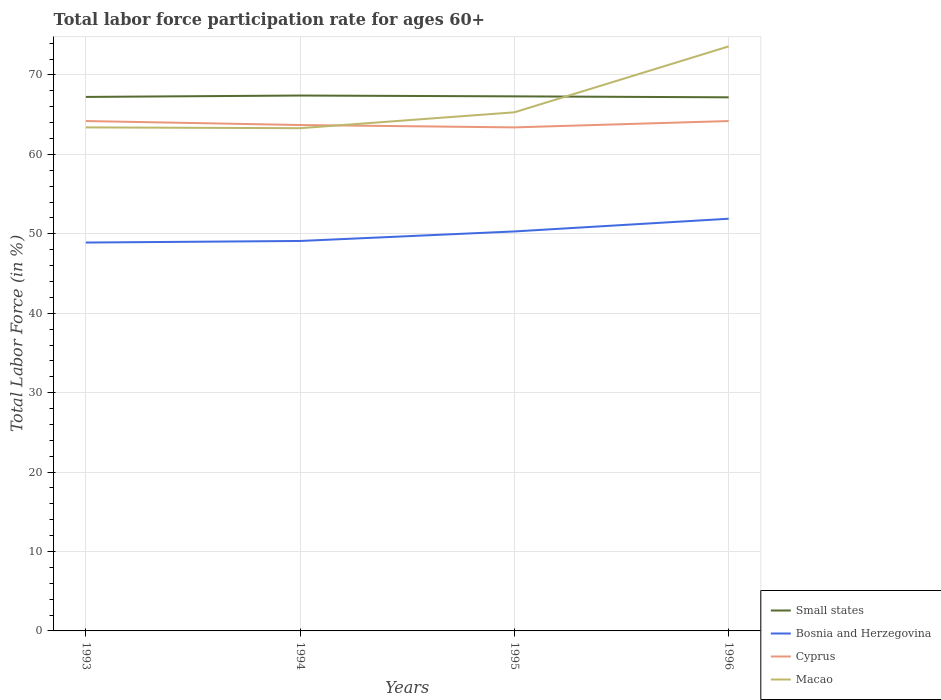How many different coloured lines are there?
Your answer should be compact. 4. Does the line corresponding to Cyprus intersect with the line corresponding to Bosnia and Herzegovina?
Give a very brief answer. No. Across all years, what is the maximum labor force participation rate in Small states?
Your answer should be very brief. 67.19. What is the total labor force participation rate in Cyprus in the graph?
Give a very brief answer. -0.5. What is the difference between the highest and the second highest labor force participation rate in Cyprus?
Provide a short and direct response. 0.8. What is the difference between the highest and the lowest labor force participation rate in Bosnia and Herzegovina?
Provide a short and direct response. 2. Is the labor force participation rate in Macao strictly greater than the labor force participation rate in Small states over the years?
Provide a succinct answer. No. How are the legend labels stacked?
Offer a very short reply. Vertical. What is the title of the graph?
Provide a succinct answer. Total labor force participation rate for ages 60+. What is the label or title of the Y-axis?
Offer a terse response. Total Labor Force (in %). What is the Total Labor Force (in %) of Small states in 1993?
Make the answer very short. 67.24. What is the Total Labor Force (in %) in Bosnia and Herzegovina in 1993?
Offer a terse response. 48.9. What is the Total Labor Force (in %) in Cyprus in 1993?
Give a very brief answer. 64.2. What is the Total Labor Force (in %) in Macao in 1993?
Offer a terse response. 63.4. What is the Total Labor Force (in %) of Small states in 1994?
Keep it short and to the point. 67.41. What is the Total Labor Force (in %) of Bosnia and Herzegovina in 1994?
Provide a short and direct response. 49.1. What is the Total Labor Force (in %) in Cyprus in 1994?
Keep it short and to the point. 63.7. What is the Total Labor Force (in %) of Macao in 1994?
Keep it short and to the point. 63.3. What is the Total Labor Force (in %) in Small states in 1995?
Ensure brevity in your answer.  67.31. What is the Total Labor Force (in %) of Bosnia and Herzegovina in 1995?
Make the answer very short. 50.3. What is the Total Labor Force (in %) in Cyprus in 1995?
Offer a terse response. 63.4. What is the Total Labor Force (in %) in Macao in 1995?
Provide a short and direct response. 65.3. What is the Total Labor Force (in %) of Small states in 1996?
Offer a very short reply. 67.19. What is the Total Labor Force (in %) in Bosnia and Herzegovina in 1996?
Provide a short and direct response. 51.9. What is the Total Labor Force (in %) in Cyprus in 1996?
Offer a very short reply. 64.2. What is the Total Labor Force (in %) of Macao in 1996?
Provide a succinct answer. 73.6. Across all years, what is the maximum Total Labor Force (in %) in Small states?
Ensure brevity in your answer.  67.41. Across all years, what is the maximum Total Labor Force (in %) of Bosnia and Herzegovina?
Your answer should be compact. 51.9. Across all years, what is the maximum Total Labor Force (in %) of Cyprus?
Provide a succinct answer. 64.2. Across all years, what is the maximum Total Labor Force (in %) in Macao?
Provide a short and direct response. 73.6. Across all years, what is the minimum Total Labor Force (in %) of Small states?
Your answer should be compact. 67.19. Across all years, what is the minimum Total Labor Force (in %) in Bosnia and Herzegovina?
Ensure brevity in your answer.  48.9. Across all years, what is the minimum Total Labor Force (in %) in Cyprus?
Offer a terse response. 63.4. Across all years, what is the minimum Total Labor Force (in %) of Macao?
Your answer should be very brief. 63.3. What is the total Total Labor Force (in %) in Small states in the graph?
Your answer should be compact. 269.14. What is the total Total Labor Force (in %) of Bosnia and Herzegovina in the graph?
Give a very brief answer. 200.2. What is the total Total Labor Force (in %) in Cyprus in the graph?
Offer a terse response. 255.5. What is the total Total Labor Force (in %) in Macao in the graph?
Your response must be concise. 265.6. What is the difference between the Total Labor Force (in %) of Small states in 1993 and that in 1994?
Your answer should be compact. -0.18. What is the difference between the Total Labor Force (in %) of Small states in 1993 and that in 1995?
Your answer should be very brief. -0.07. What is the difference between the Total Labor Force (in %) in Cyprus in 1993 and that in 1995?
Offer a terse response. 0.8. What is the difference between the Total Labor Force (in %) of Macao in 1993 and that in 1995?
Provide a short and direct response. -1.9. What is the difference between the Total Labor Force (in %) in Small states in 1993 and that in 1996?
Provide a succinct answer. 0.05. What is the difference between the Total Labor Force (in %) of Macao in 1993 and that in 1996?
Provide a short and direct response. -10.2. What is the difference between the Total Labor Force (in %) of Small states in 1994 and that in 1995?
Offer a terse response. 0.1. What is the difference between the Total Labor Force (in %) of Cyprus in 1994 and that in 1995?
Provide a short and direct response. 0.3. What is the difference between the Total Labor Force (in %) of Macao in 1994 and that in 1995?
Offer a terse response. -2. What is the difference between the Total Labor Force (in %) in Small states in 1994 and that in 1996?
Your answer should be very brief. 0.23. What is the difference between the Total Labor Force (in %) of Bosnia and Herzegovina in 1994 and that in 1996?
Your answer should be very brief. -2.8. What is the difference between the Total Labor Force (in %) in Cyprus in 1994 and that in 1996?
Provide a succinct answer. -0.5. What is the difference between the Total Labor Force (in %) of Small states in 1995 and that in 1996?
Make the answer very short. 0.12. What is the difference between the Total Labor Force (in %) in Bosnia and Herzegovina in 1995 and that in 1996?
Make the answer very short. -1.6. What is the difference between the Total Labor Force (in %) of Cyprus in 1995 and that in 1996?
Ensure brevity in your answer.  -0.8. What is the difference between the Total Labor Force (in %) of Small states in 1993 and the Total Labor Force (in %) of Bosnia and Herzegovina in 1994?
Give a very brief answer. 18.14. What is the difference between the Total Labor Force (in %) in Small states in 1993 and the Total Labor Force (in %) in Cyprus in 1994?
Keep it short and to the point. 3.54. What is the difference between the Total Labor Force (in %) in Small states in 1993 and the Total Labor Force (in %) in Macao in 1994?
Give a very brief answer. 3.94. What is the difference between the Total Labor Force (in %) in Bosnia and Herzegovina in 1993 and the Total Labor Force (in %) in Cyprus in 1994?
Make the answer very short. -14.8. What is the difference between the Total Labor Force (in %) in Bosnia and Herzegovina in 1993 and the Total Labor Force (in %) in Macao in 1994?
Offer a very short reply. -14.4. What is the difference between the Total Labor Force (in %) of Cyprus in 1993 and the Total Labor Force (in %) of Macao in 1994?
Offer a very short reply. 0.9. What is the difference between the Total Labor Force (in %) of Small states in 1993 and the Total Labor Force (in %) of Bosnia and Herzegovina in 1995?
Ensure brevity in your answer.  16.94. What is the difference between the Total Labor Force (in %) in Small states in 1993 and the Total Labor Force (in %) in Cyprus in 1995?
Provide a succinct answer. 3.84. What is the difference between the Total Labor Force (in %) in Small states in 1993 and the Total Labor Force (in %) in Macao in 1995?
Your response must be concise. 1.94. What is the difference between the Total Labor Force (in %) in Bosnia and Herzegovina in 1993 and the Total Labor Force (in %) in Macao in 1995?
Give a very brief answer. -16.4. What is the difference between the Total Labor Force (in %) of Cyprus in 1993 and the Total Labor Force (in %) of Macao in 1995?
Make the answer very short. -1.1. What is the difference between the Total Labor Force (in %) of Small states in 1993 and the Total Labor Force (in %) of Bosnia and Herzegovina in 1996?
Offer a terse response. 15.34. What is the difference between the Total Labor Force (in %) of Small states in 1993 and the Total Labor Force (in %) of Cyprus in 1996?
Offer a terse response. 3.04. What is the difference between the Total Labor Force (in %) of Small states in 1993 and the Total Labor Force (in %) of Macao in 1996?
Ensure brevity in your answer.  -6.36. What is the difference between the Total Labor Force (in %) in Bosnia and Herzegovina in 1993 and the Total Labor Force (in %) in Cyprus in 1996?
Keep it short and to the point. -15.3. What is the difference between the Total Labor Force (in %) in Bosnia and Herzegovina in 1993 and the Total Labor Force (in %) in Macao in 1996?
Your answer should be compact. -24.7. What is the difference between the Total Labor Force (in %) in Cyprus in 1993 and the Total Labor Force (in %) in Macao in 1996?
Your response must be concise. -9.4. What is the difference between the Total Labor Force (in %) in Small states in 1994 and the Total Labor Force (in %) in Bosnia and Herzegovina in 1995?
Make the answer very short. 17.11. What is the difference between the Total Labor Force (in %) of Small states in 1994 and the Total Labor Force (in %) of Cyprus in 1995?
Ensure brevity in your answer.  4.01. What is the difference between the Total Labor Force (in %) of Small states in 1994 and the Total Labor Force (in %) of Macao in 1995?
Provide a succinct answer. 2.11. What is the difference between the Total Labor Force (in %) of Bosnia and Herzegovina in 1994 and the Total Labor Force (in %) of Cyprus in 1995?
Your response must be concise. -14.3. What is the difference between the Total Labor Force (in %) of Bosnia and Herzegovina in 1994 and the Total Labor Force (in %) of Macao in 1995?
Provide a succinct answer. -16.2. What is the difference between the Total Labor Force (in %) of Small states in 1994 and the Total Labor Force (in %) of Bosnia and Herzegovina in 1996?
Provide a succinct answer. 15.51. What is the difference between the Total Labor Force (in %) in Small states in 1994 and the Total Labor Force (in %) in Cyprus in 1996?
Give a very brief answer. 3.21. What is the difference between the Total Labor Force (in %) of Small states in 1994 and the Total Labor Force (in %) of Macao in 1996?
Offer a terse response. -6.19. What is the difference between the Total Labor Force (in %) in Bosnia and Herzegovina in 1994 and the Total Labor Force (in %) in Cyprus in 1996?
Your answer should be compact. -15.1. What is the difference between the Total Labor Force (in %) in Bosnia and Herzegovina in 1994 and the Total Labor Force (in %) in Macao in 1996?
Your answer should be very brief. -24.5. What is the difference between the Total Labor Force (in %) of Small states in 1995 and the Total Labor Force (in %) of Bosnia and Herzegovina in 1996?
Your answer should be very brief. 15.41. What is the difference between the Total Labor Force (in %) in Small states in 1995 and the Total Labor Force (in %) in Cyprus in 1996?
Your response must be concise. 3.11. What is the difference between the Total Labor Force (in %) in Small states in 1995 and the Total Labor Force (in %) in Macao in 1996?
Your answer should be very brief. -6.29. What is the difference between the Total Labor Force (in %) of Bosnia and Herzegovina in 1995 and the Total Labor Force (in %) of Cyprus in 1996?
Ensure brevity in your answer.  -13.9. What is the difference between the Total Labor Force (in %) in Bosnia and Herzegovina in 1995 and the Total Labor Force (in %) in Macao in 1996?
Make the answer very short. -23.3. What is the difference between the Total Labor Force (in %) in Cyprus in 1995 and the Total Labor Force (in %) in Macao in 1996?
Provide a short and direct response. -10.2. What is the average Total Labor Force (in %) of Small states per year?
Provide a succinct answer. 67.29. What is the average Total Labor Force (in %) in Bosnia and Herzegovina per year?
Offer a very short reply. 50.05. What is the average Total Labor Force (in %) of Cyprus per year?
Ensure brevity in your answer.  63.88. What is the average Total Labor Force (in %) in Macao per year?
Provide a succinct answer. 66.4. In the year 1993, what is the difference between the Total Labor Force (in %) in Small states and Total Labor Force (in %) in Bosnia and Herzegovina?
Give a very brief answer. 18.34. In the year 1993, what is the difference between the Total Labor Force (in %) in Small states and Total Labor Force (in %) in Cyprus?
Offer a terse response. 3.04. In the year 1993, what is the difference between the Total Labor Force (in %) in Small states and Total Labor Force (in %) in Macao?
Offer a very short reply. 3.84. In the year 1993, what is the difference between the Total Labor Force (in %) of Bosnia and Herzegovina and Total Labor Force (in %) of Cyprus?
Give a very brief answer. -15.3. In the year 1993, what is the difference between the Total Labor Force (in %) of Bosnia and Herzegovina and Total Labor Force (in %) of Macao?
Make the answer very short. -14.5. In the year 1994, what is the difference between the Total Labor Force (in %) of Small states and Total Labor Force (in %) of Bosnia and Herzegovina?
Make the answer very short. 18.31. In the year 1994, what is the difference between the Total Labor Force (in %) in Small states and Total Labor Force (in %) in Cyprus?
Ensure brevity in your answer.  3.71. In the year 1994, what is the difference between the Total Labor Force (in %) in Small states and Total Labor Force (in %) in Macao?
Ensure brevity in your answer.  4.11. In the year 1994, what is the difference between the Total Labor Force (in %) of Bosnia and Herzegovina and Total Labor Force (in %) of Cyprus?
Ensure brevity in your answer.  -14.6. In the year 1994, what is the difference between the Total Labor Force (in %) of Bosnia and Herzegovina and Total Labor Force (in %) of Macao?
Your answer should be very brief. -14.2. In the year 1994, what is the difference between the Total Labor Force (in %) in Cyprus and Total Labor Force (in %) in Macao?
Give a very brief answer. 0.4. In the year 1995, what is the difference between the Total Labor Force (in %) in Small states and Total Labor Force (in %) in Bosnia and Herzegovina?
Offer a terse response. 17.01. In the year 1995, what is the difference between the Total Labor Force (in %) in Small states and Total Labor Force (in %) in Cyprus?
Your response must be concise. 3.91. In the year 1995, what is the difference between the Total Labor Force (in %) of Small states and Total Labor Force (in %) of Macao?
Your response must be concise. 2.01. In the year 1996, what is the difference between the Total Labor Force (in %) of Small states and Total Labor Force (in %) of Bosnia and Herzegovina?
Ensure brevity in your answer.  15.29. In the year 1996, what is the difference between the Total Labor Force (in %) of Small states and Total Labor Force (in %) of Cyprus?
Give a very brief answer. 2.99. In the year 1996, what is the difference between the Total Labor Force (in %) of Small states and Total Labor Force (in %) of Macao?
Provide a short and direct response. -6.41. In the year 1996, what is the difference between the Total Labor Force (in %) of Bosnia and Herzegovina and Total Labor Force (in %) of Macao?
Provide a short and direct response. -21.7. What is the ratio of the Total Labor Force (in %) of Bosnia and Herzegovina in 1993 to that in 1994?
Keep it short and to the point. 1. What is the ratio of the Total Labor Force (in %) of Cyprus in 1993 to that in 1994?
Offer a very short reply. 1.01. What is the ratio of the Total Labor Force (in %) of Bosnia and Herzegovina in 1993 to that in 1995?
Ensure brevity in your answer.  0.97. What is the ratio of the Total Labor Force (in %) in Cyprus in 1993 to that in 1995?
Keep it short and to the point. 1.01. What is the ratio of the Total Labor Force (in %) of Macao in 1993 to that in 1995?
Ensure brevity in your answer.  0.97. What is the ratio of the Total Labor Force (in %) of Small states in 1993 to that in 1996?
Provide a succinct answer. 1. What is the ratio of the Total Labor Force (in %) of Bosnia and Herzegovina in 1993 to that in 1996?
Offer a terse response. 0.94. What is the ratio of the Total Labor Force (in %) in Macao in 1993 to that in 1996?
Provide a short and direct response. 0.86. What is the ratio of the Total Labor Force (in %) in Small states in 1994 to that in 1995?
Ensure brevity in your answer.  1. What is the ratio of the Total Labor Force (in %) of Bosnia and Herzegovina in 1994 to that in 1995?
Provide a succinct answer. 0.98. What is the ratio of the Total Labor Force (in %) in Cyprus in 1994 to that in 1995?
Provide a short and direct response. 1. What is the ratio of the Total Labor Force (in %) in Macao in 1994 to that in 1995?
Provide a short and direct response. 0.97. What is the ratio of the Total Labor Force (in %) of Bosnia and Herzegovina in 1994 to that in 1996?
Ensure brevity in your answer.  0.95. What is the ratio of the Total Labor Force (in %) of Cyprus in 1994 to that in 1996?
Make the answer very short. 0.99. What is the ratio of the Total Labor Force (in %) in Macao in 1994 to that in 1996?
Make the answer very short. 0.86. What is the ratio of the Total Labor Force (in %) in Bosnia and Herzegovina in 1995 to that in 1996?
Keep it short and to the point. 0.97. What is the ratio of the Total Labor Force (in %) of Cyprus in 1995 to that in 1996?
Ensure brevity in your answer.  0.99. What is the ratio of the Total Labor Force (in %) in Macao in 1995 to that in 1996?
Make the answer very short. 0.89. What is the difference between the highest and the second highest Total Labor Force (in %) in Small states?
Your answer should be compact. 0.1. What is the difference between the highest and the lowest Total Labor Force (in %) in Small states?
Your response must be concise. 0.23. What is the difference between the highest and the lowest Total Labor Force (in %) of Cyprus?
Give a very brief answer. 0.8. 